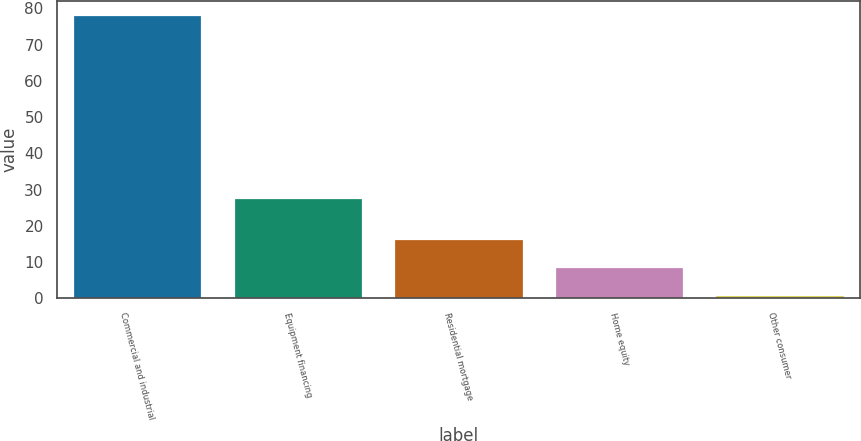Convert chart. <chart><loc_0><loc_0><loc_500><loc_500><bar_chart><fcel>Commercial and industrial<fcel>Equipment financing<fcel>Residential mortgage<fcel>Home equity<fcel>Other consumer<nl><fcel>78.2<fcel>27.6<fcel>16.44<fcel>8.72<fcel>1<nl></chart> 